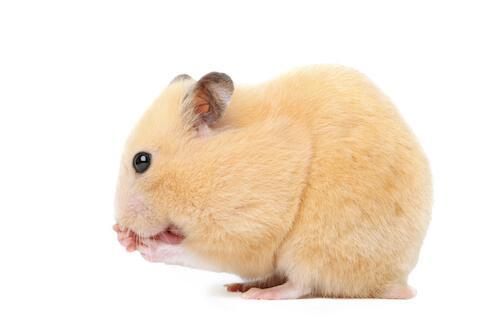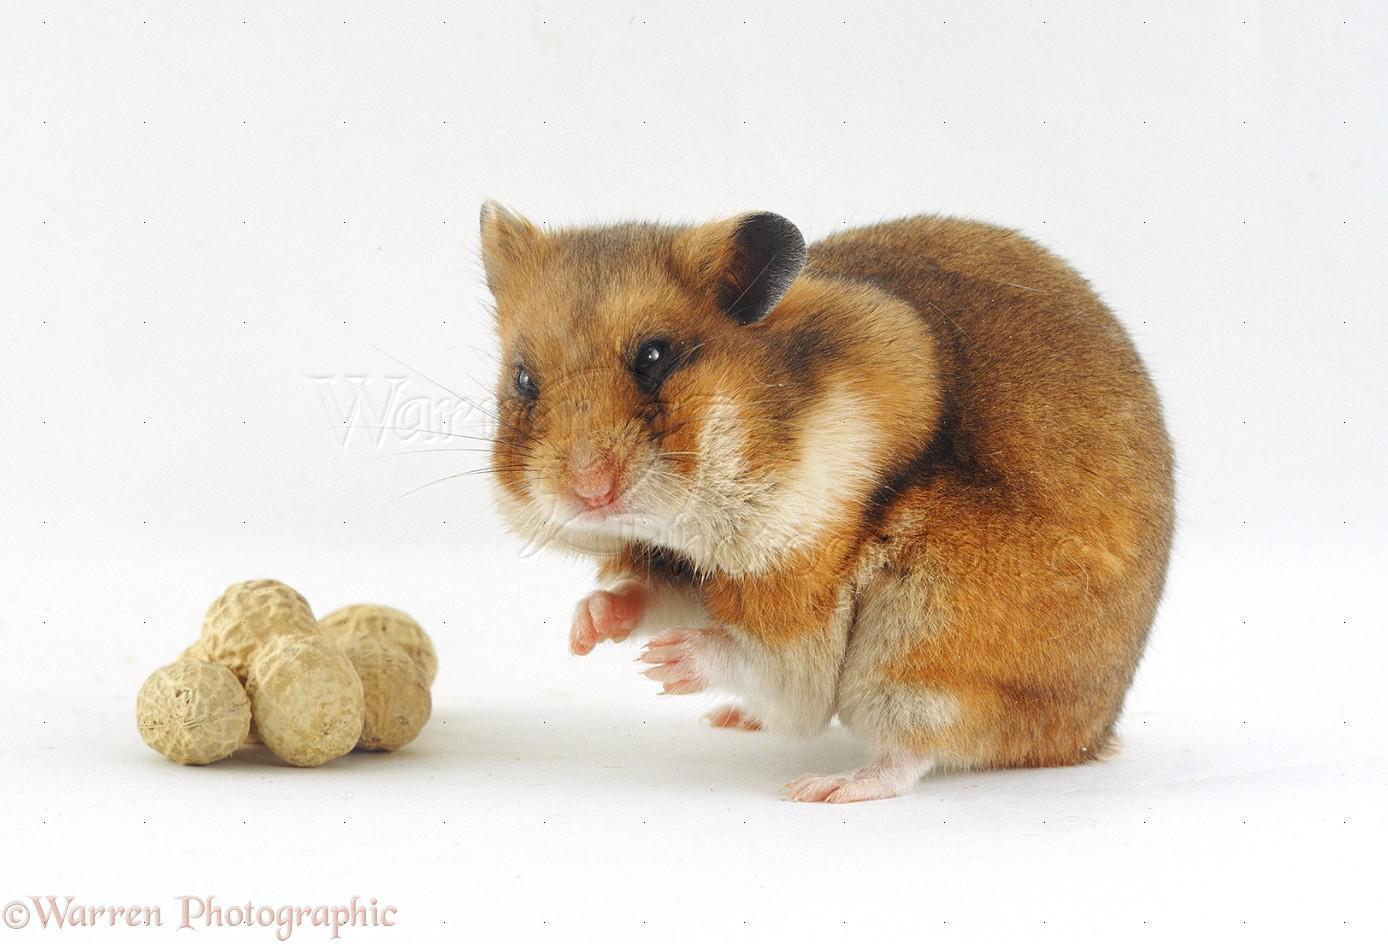The first image is the image on the left, the second image is the image on the right. For the images shown, is this caption "An edible item is to the left of a small rodent in one image." true? Answer yes or no. Yes. The first image is the image on the left, the second image is the image on the right. Examine the images to the left and right. Is the description "Food sits on the surface in front of a rodent in one of the images." accurate? Answer yes or no. Yes. 